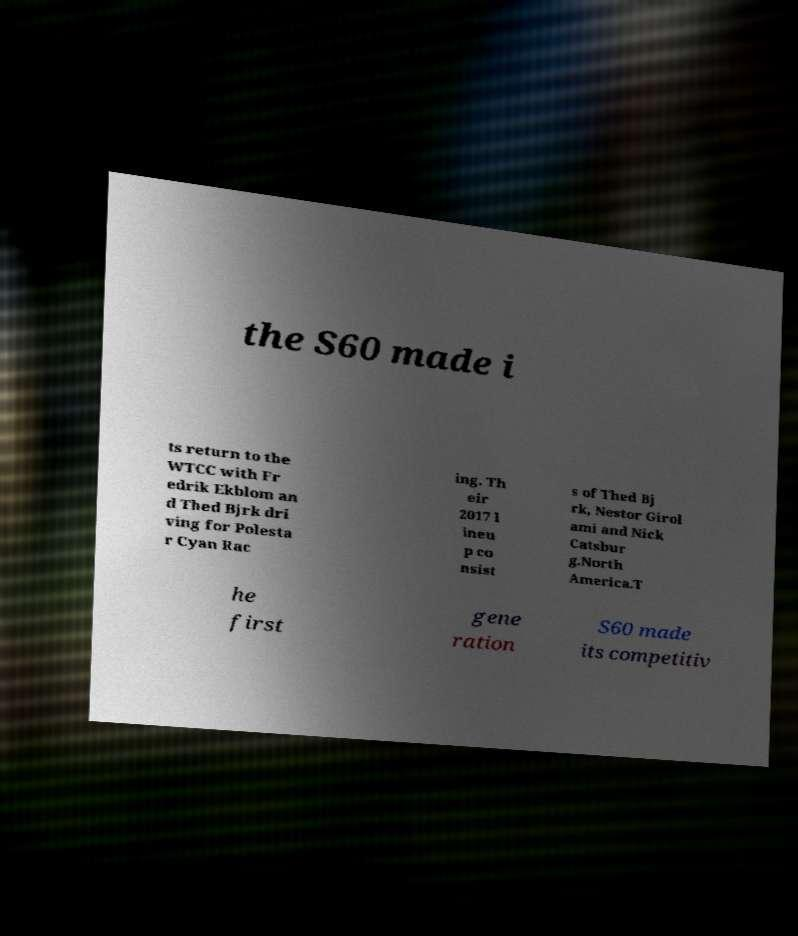Can you accurately transcribe the text from the provided image for me? the S60 made i ts return to the WTCC with Fr edrik Ekblom an d Thed Bjrk dri ving for Polesta r Cyan Rac ing. Th eir 2017 l ineu p co nsist s of Thed Bj rk, Nestor Girol ami and Nick Catsbur g.North America.T he first gene ration S60 made its competitiv 